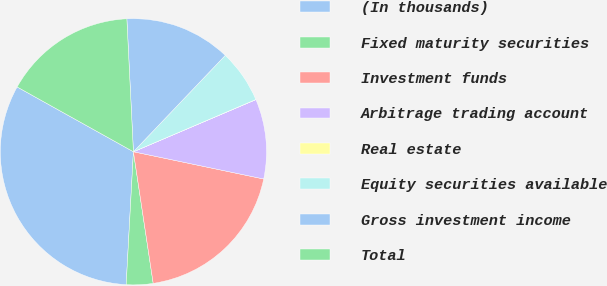<chart> <loc_0><loc_0><loc_500><loc_500><pie_chart><fcel>(In thousands)<fcel>Fixed maturity securities<fcel>Investment funds<fcel>Arbitrage trading account<fcel>Real estate<fcel>Equity securities available<fcel>Gross investment income<fcel>Total<nl><fcel>32.22%<fcel>3.24%<fcel>19.34%<fcel>9.68%<fcel>0.02%<fcel>6.46%<fcel>12.9%<fcel>16.12%<nl></chart> 